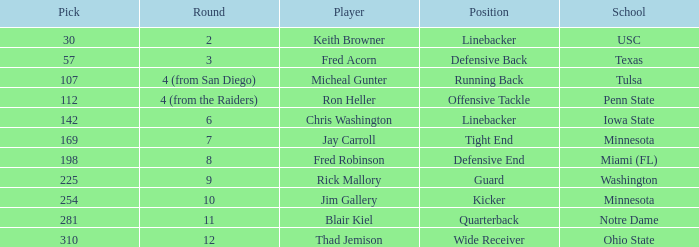What is the loftiest mountain from washington? 225.0. Would you be able to parse every entry in this table? {'header': ['Pick', 'Round', 'Player', 'Position', 'School'], 'rows': [['30', '2', 'Keith Browner', 'Linebacker', 'USC'], ['57', '3', 'Fred Acorn', 'Defensive Back', 'Texas'], ['107', '4 (from San Diego)', 'Micheal Gunter', 'Running Back', 'Tulsa'], ['112', '4 (from the Raiders)', 'Ron Heller', 'Offensive Tackle', 'Penn State'], ['142', '6', 'Chris Washington', 'Linebacker', 'Iowa State'], ['169', '7', 'Jay Carroll', 'Tight End', 'Minnesota'], ['198', '8', 'Fred Robinson', 'Defensive End', 'Miami (FL)'], ['225', '9', 'Rick Mallory', 'Guard', 'Washington'], ['254', '10', 'Jim Gallery', 'Kicker', 'Minnesota'], ['281', '11', 'Blair Kiel', 'Quarterback', 'Notre Dame'], ['310', '12', 'Thad Jemison', 'Wide Receiver', 'Ohio State']]} 